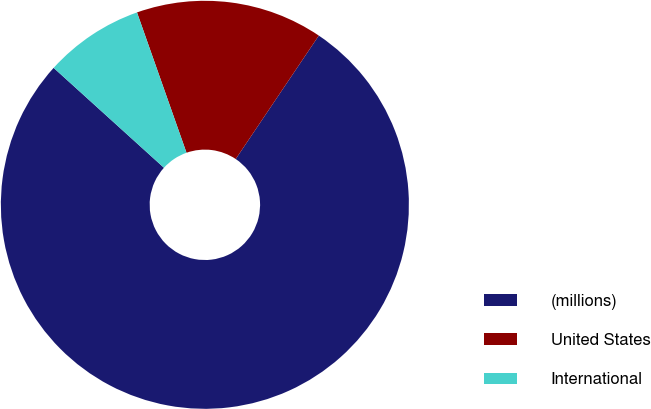<chart> <loc_0><loc_0><loc_500><loc_500><pie_chart><fcel>(millions)<fcel>United States<fcel>International<nl><fcel>77.28%<fcel>14.83%<fcel>7.89%<nl></chart> 